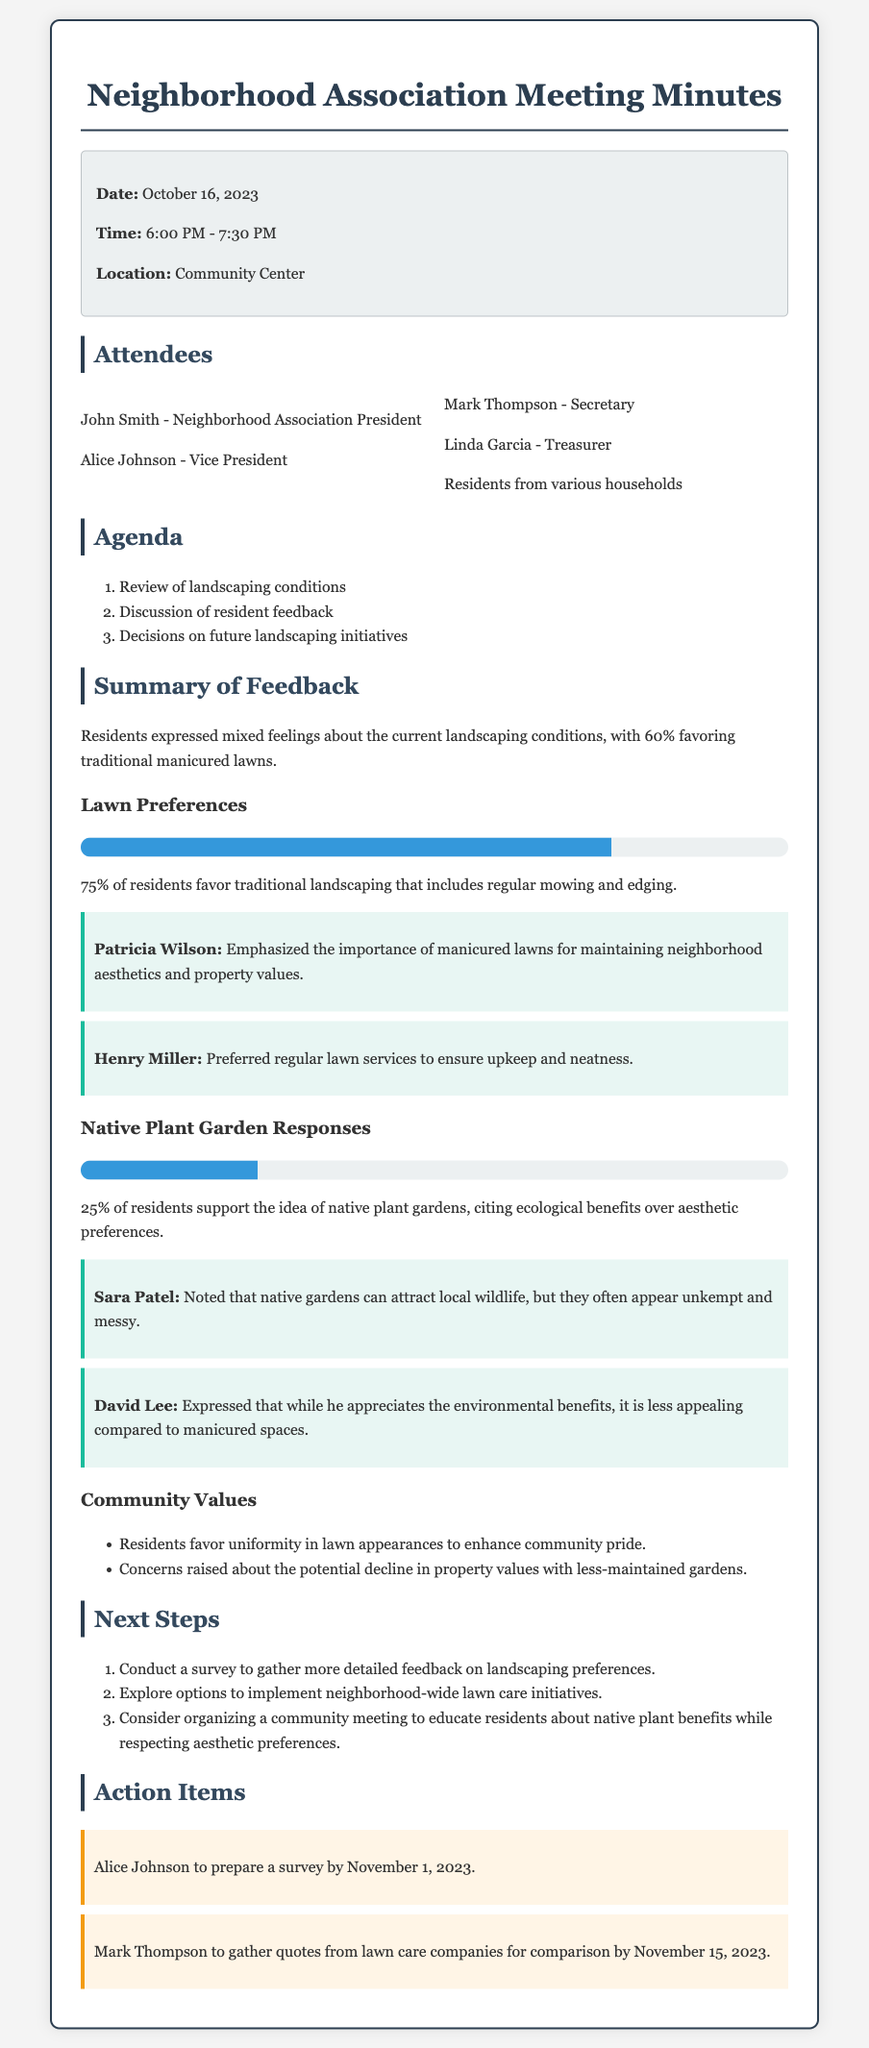What percentage of residents favor traditional manicured lawns? The document states that 60% of residents favor traditional manicured lawns.
Answer: 60% How many residents favor traditional landscaping? According to the feedback summary, 75% of residents favor traditional landscaping.
Answer: 75% Who emphasized the importance of manicured lawns? Patricia Wilson is mentioned as emphasizing the importance of manicured lawns for neighborhood aesthetics.
Answer: Patricia Wilson What percentage of residents support native plant gardens? The document indicates that 25% of residents support the idea of native plant gardens.
Answer: 25% What is one concern raised regarding less-maintained gardens? There is concern about the potential decline in property values with less-maintained gardens.
Answer: Property values Who is responsible for preparing a survey? The action item states that Alice Johnson is to prepare a survey.
Answer: Alice Johnson What date is the survey due? The document mentions the survey is due by November 1, 2023.
Answer: November 1, 2023 What did David Lee express about native plant gardens? David Lee expressed that while he appreciates the environmental benefits, they are less appealing compared to manicured spaces.
Answer: Less appealing What are residents favoring to enhance community pride? The document notes that residents favor uniformity in lawn appearances to enhance community pride.
Answer: Uniformity 